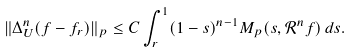<formula> <loc_0><loc_0><loc_500><loc_500>\| \Delta _ { U } ^ { n } ( f - f _ { r } ) \| _ { p } \leq C \int _ { r } ^ { 1 } ( 1 - s ) ^ { n - 1 } M _ { p } ( s , \mathcal { R } ^ { n } f ) \, d s .</formula> 